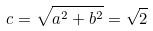Convert formula to latex. <formula><loc_0><loc_0><loc_500><loc_500>c = \sqrt { a ^ { 2 } + b ^ { 2 } } = \sqrt { 2 }</formula> 